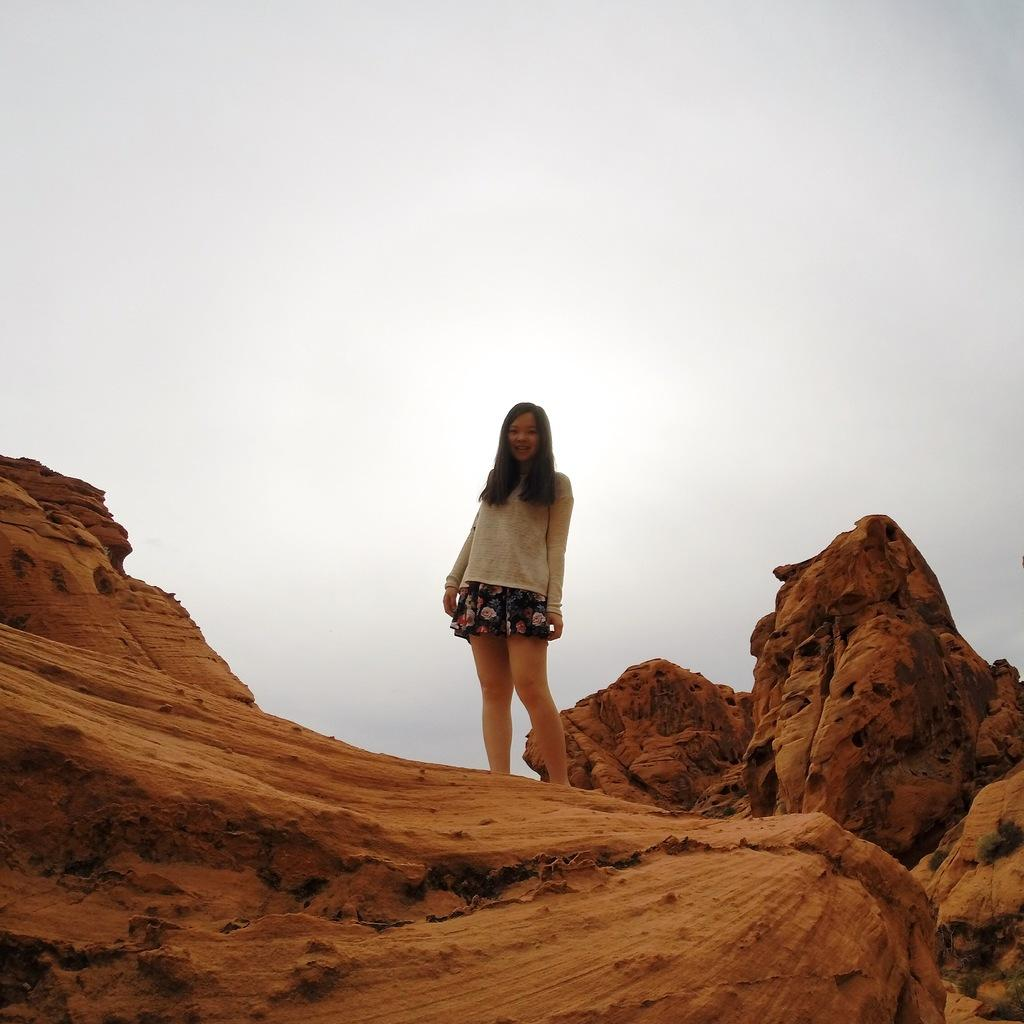Who is the main subject in the image? There is a girl in the image. What is the girl standing on? The girl is standing on a red dune. What type of wine is the girl holding in the image? There is no wine present in the image; the girl is standing on a red dune. 